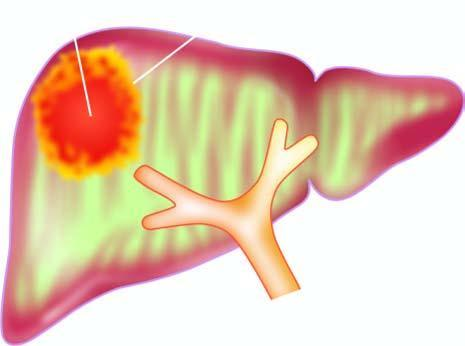what is irregular and necrotic?
Answer the question using a single word or phrase. Amoebic liver abscess's wall 